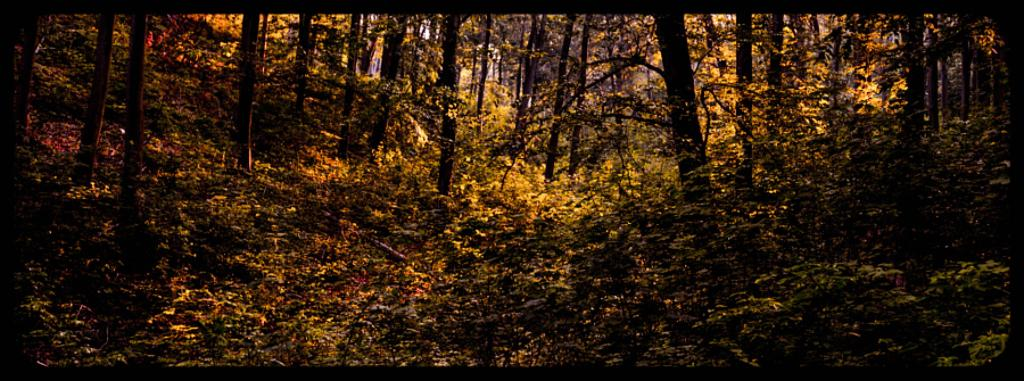What type of vegetation can be seen in the image? There are trees and plants in the image. What type of ground cover is visible in the image? There is grass visible in the image. What else can be found on the ground in the image? There are other objects on the ground in the image. Can you see any elbows in the image? There are no elbows present in the image. What type of duck can be seen swimming in the pond in the image? There is no pond or duck present in the image. 